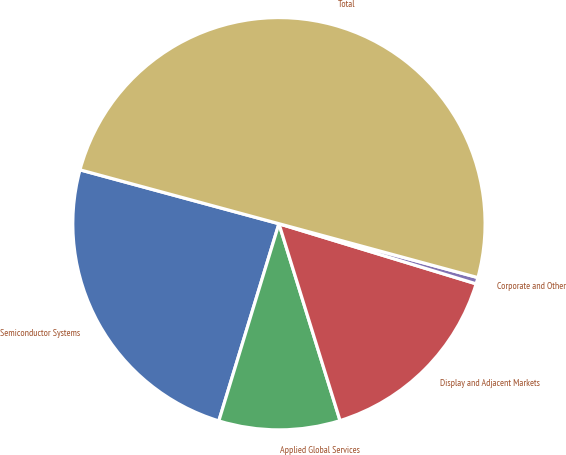Convert chart. <chart><loc_0><loc_0><loc_500><loc_500><pie_chart><fcel>Semiconductor Systems<fcel>Applied Global Services<fcel>Display and Adjacent Markets<fcel>Corporate and Other<fcel>Total<nl><fcel>24.5%<fcel>9.5%<fcel>15.5%<fcel>0.5%<fcel>50.0%<nl></chart> 